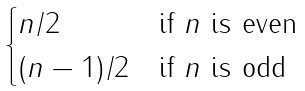Convert formula to latex. <formula><loc_0><loc_0><loc_500><loc_500>\begin{cases} n / 2 & \text {if $n$ is even} \\ ( n - 1 ) / 2 & \text {if $n$ is odd} \end{cases}</formula> 